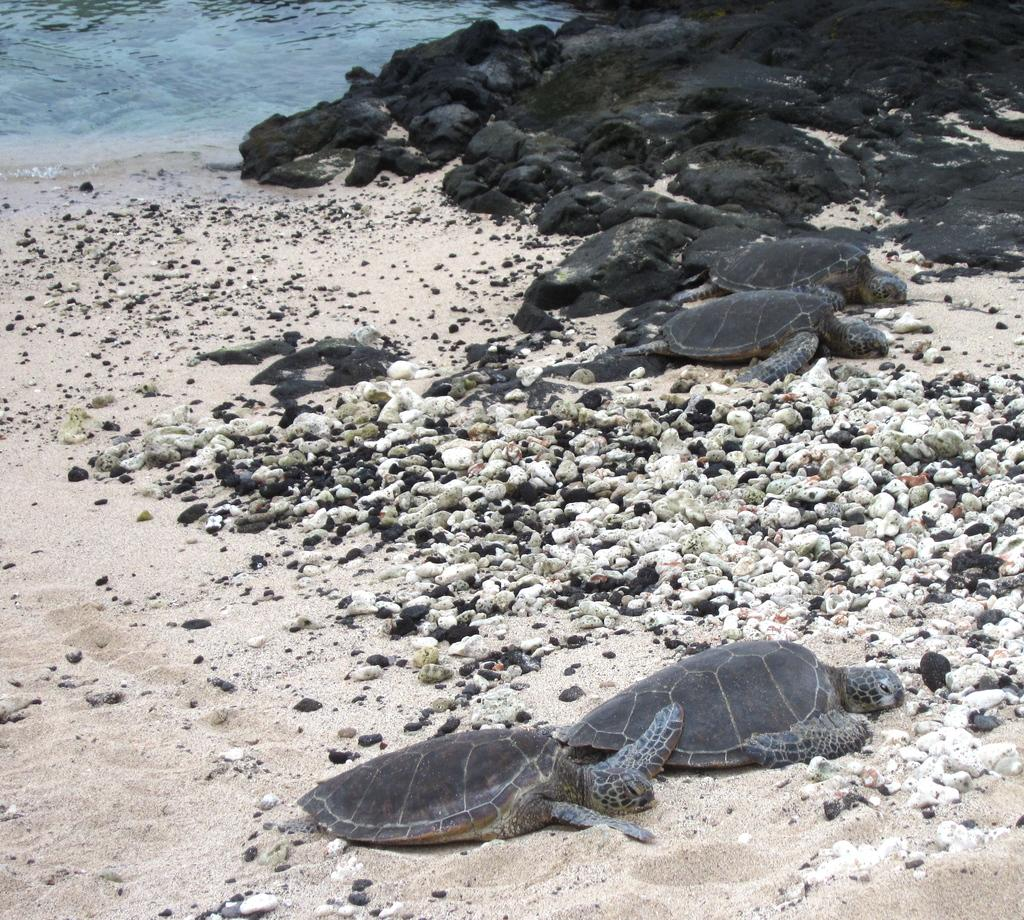What animals can be seen on the sand in the image? There are tortoises on the sand in the image. What other objects or features are near the tortoises? There are rocks beside the tortoises. Where is the water located in the image? The water is in the left top corner of the image. What type of cart can be seen in the image? There is no cart present in the image. Can you hear a whistle in the image? There is no sound, including a whistle, present in the image. 